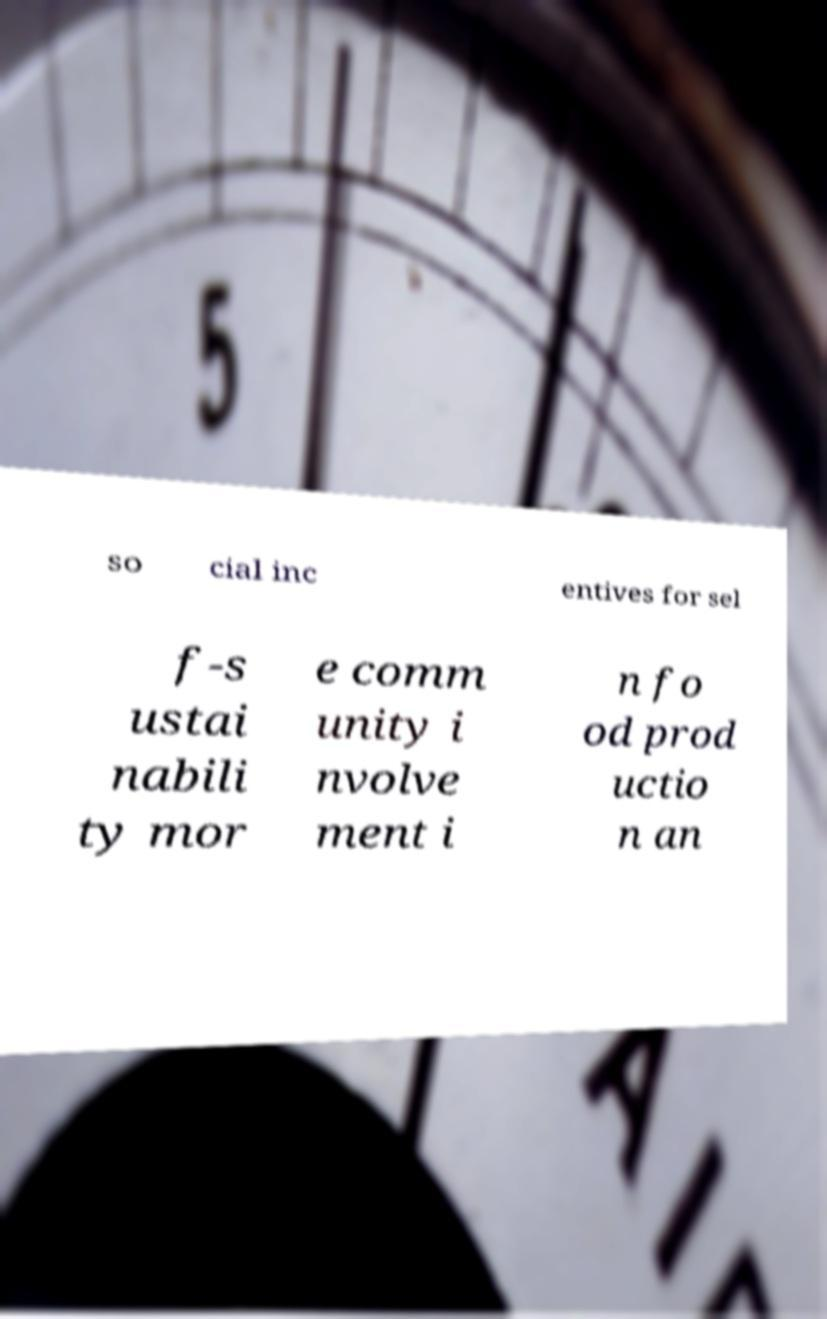Could you extract and type out the text from this image? so cial inc entives for sel f-s ustai nabili ty mor e comm unity i nvolve ment i n fo od prod uctio n an 